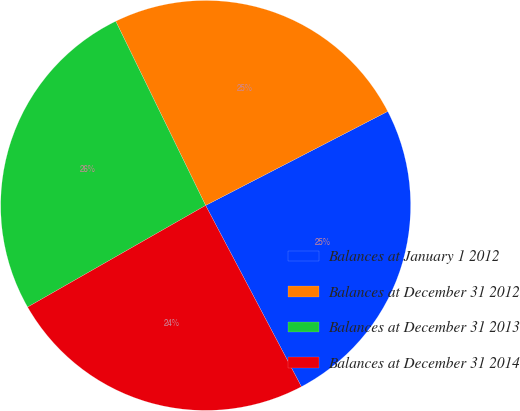Convert chart to OTSL. <chart><loc_0><loc_0><loc_500><loc_500><pie_chart><fcel>Balances at January 1 2012<fcel>Balances at December 31 2012<fcel>Balances at December 31 2013<fcel>Balances at December 31 2014<nl><fcel>24.85%<fcel>24.64%<fcel>26.03%<fcel>24.48%<nl></chart> 